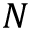Convert formula to latex. <formula><loc_0><loc_0><loc_500><loc_500>N</formula> 